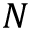Convert formula to latex. <formula><loc_0><loc_0><loc_500><loc_500>N</formula> 